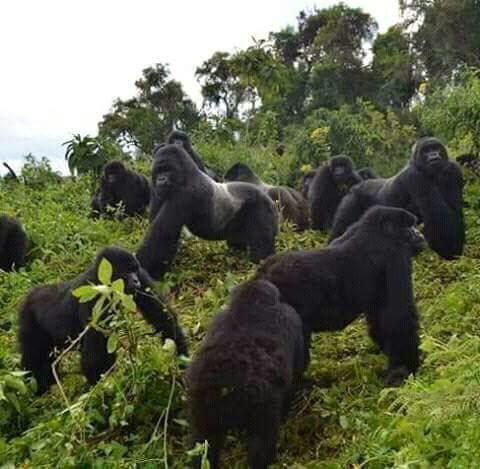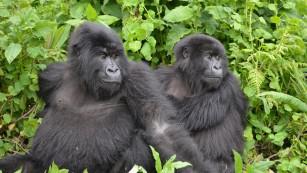The first image is the image on the left, the second image is the image on the right. Considering the images on both sides, is "The right image includes an adult gorilla on all fours in the foreground, and the left image includes a large gorilla, multiple people, and someone upside down and off their feet." valid? Answer yes or no. No. The first image is the image on the left, the second image is the image on the right. Given the left and right images, does the statement "There are at least two men in the image with one silverback gorilla." hold true? Answer yes or no. No. 